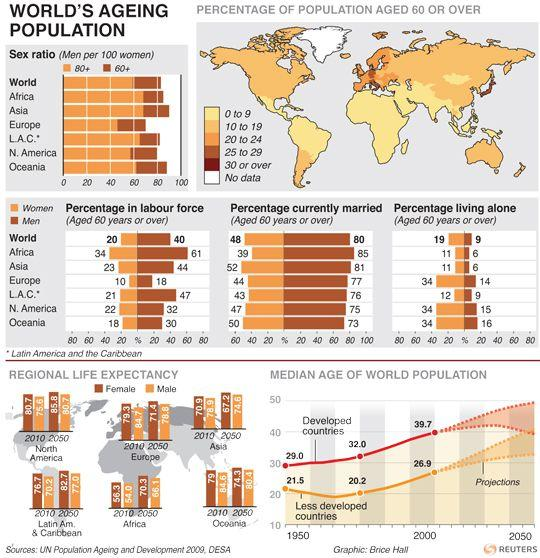List a handful of essential elements in this visual. It is estimated that currently, approximately 128% of both men and women in the world are currently married. According to recent statistics, it is reported that approximately 124% of women and men in Africa are currently married. It is estimated that approximately 28% of women and men around the world are currently living alone. 